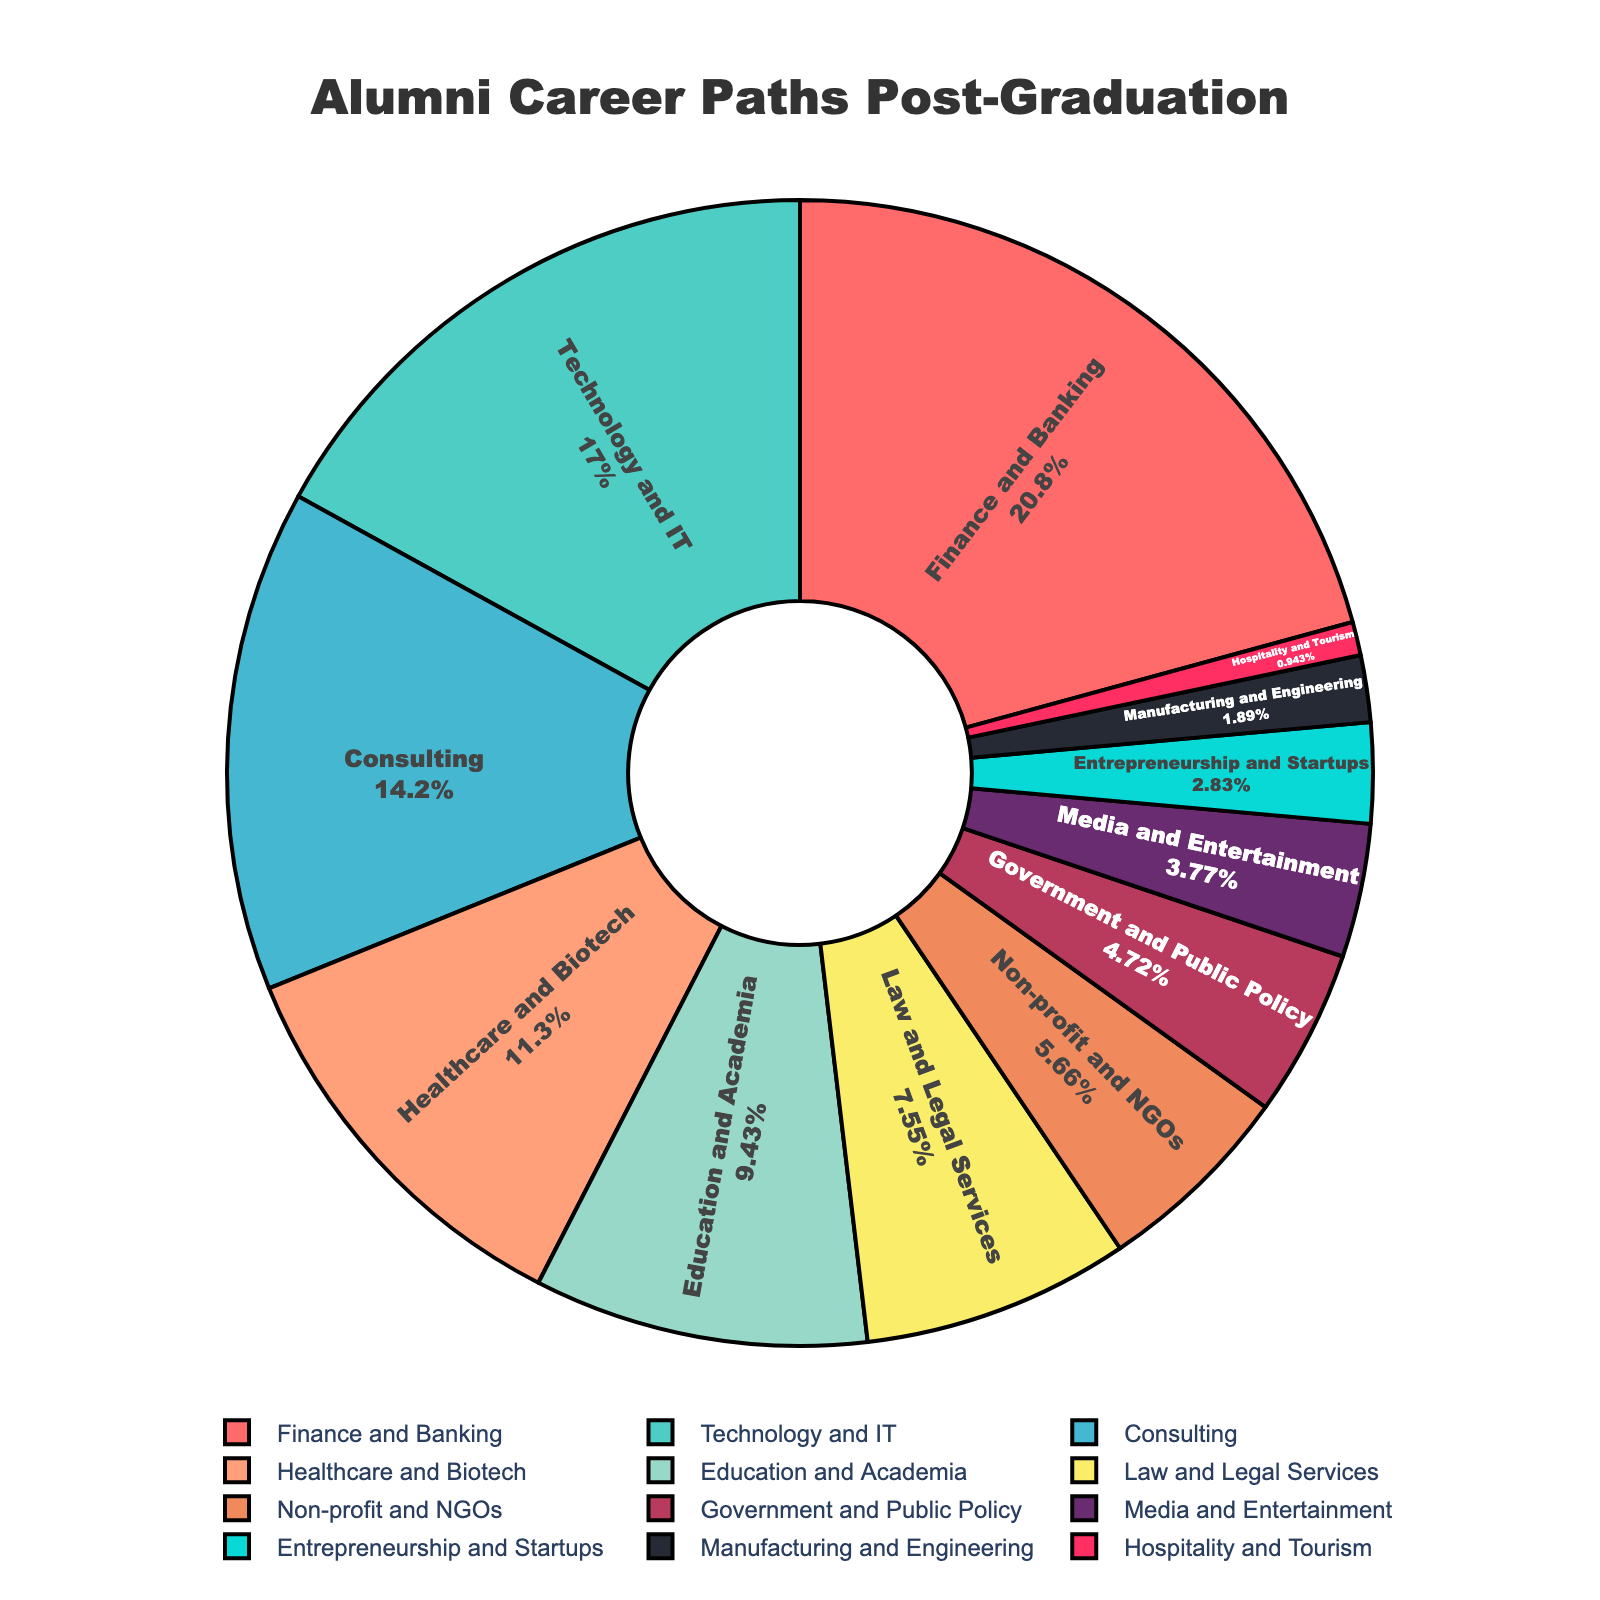What is the largest career path percentage for alumni? To determine the largest career path percentage for alumni, look for the segment in the pie chart with the highest percentage label. In this case, it is "Finance and Banking" with 22%.
Answer: Finance and Banking Which career path is more popular, Technology and IT or Healthcare and Biotech? Comparing the two segments in the pie chart, Technology and IT has 18% while Healthcare and Biotech has 12%. Therefore, Technology and IT is more popular.
Answer: Technology and IT What is the combined percentage of alumni working in Consulting and Law and Legal Services? To find the combined percentage, sum the percentages of Consulting (15%) and Law and Legal Services (8%). This equals 15% + 8% = 23%.
Answer: 23% Which career path has a slightly higher percentage than Education and Academia? By examining the percentages in the chart, Consulting has 15%, which is slightly higher than Education and Academia's 10%.
Answer: Consulting What is the percentage difference between Finance and Banking and Entrepreneurship and Startups? The difference in percentages is calculated by subtracting the smaller percentage from the larger one. Finance and Banking is 22% and Entrepreneurship and Startups is 3%; therefore, the difference is 22% - 3% = 19%.
Answer: 19% What career path is represented by a light green color? From the color palette provided and the order of the career paths, the light green color represents the Technology and IT segment.
Answer: Technology and IT How many career paths have a percentage of 10% or higher? By examining the pie chart, count the number of segments with percentages of 10% or higher: Finance and Banking (22%), Technology and IT (18%), Consulting (15%), Healthcare and Biotech (12%), and Education and Academia (10%). There are 5 such career paths.
Answer: 5 Which is the smallest represented career path in the pie chart? The smallest segment by percentage in the pie chart is Hospitality and Tourism with 1%.
Answer: Hospitality and Tourism What is the combined percentage for career paths with less than 5% representation? Adding up the smaller segments: Media and Entertainment (4%), Entrepreneurship and Startups (3%), Manufacturing and Engineering (2%), and Hospitality and Tourism (1%) gives 4% + 3% + 2% + 1% = 10%.
Answer: 10% Explain the dominance of the top three career paths in terms of total percentage. To see the dominance of the top three career paths, sum their percentages: Finance and Banking (22%), Technology and IT (18%), and Consulting (15%). This totals 22% + 18% + 15% = 55%, which means that these three career paths collectively account for more than half of the alumni career paths.
Answer: 55% 